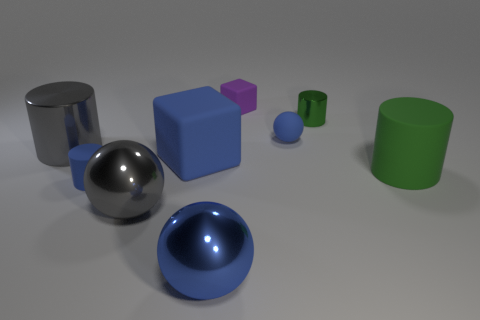There is a gray shiny thing that is behind the big rubber block; is it the same shape as the rubber object on the right side of the green metallic cylinder?
Your response must be concise. Yes. Are there an equal number of purple objects that are in front of the big blue matte cube and gray metal balls that are behind the tiny shiny object?
Make the answer very short. Yes. What shape is the big blue thing that is behind the blue matte cylinder to the left of the gray metal object on the right side of the large gray metal cylinder?
Keep it short and to the point. Cube. Does the small blue thing that is behind the blue rubber cylinder have the same material as the large gray thing that is to the right of the big gray metal cylinder?
Make the answer very short. No. There is a blue object that is right of the purple matte block; what shape is it?
Offer a very short reply. Sphere. Are there fewer large green rubber cylinders than gray metal objects?
Give a very brief answer. Yes. There is a matte cube that is behind the small blue matte object behind the gray cylinder; are there any matte blocks in front of it?
Your answer should be very brief. Yes. What number of metallic objects are small blocks or big green cylinders?
Make the answer very short. 0. Is the tiny matte cylinder the same color as the small cube?
Make the answer very short. No. What number of blocks are on the left side of the big blue shiny thing?
Keep it short and to the point. 1. 